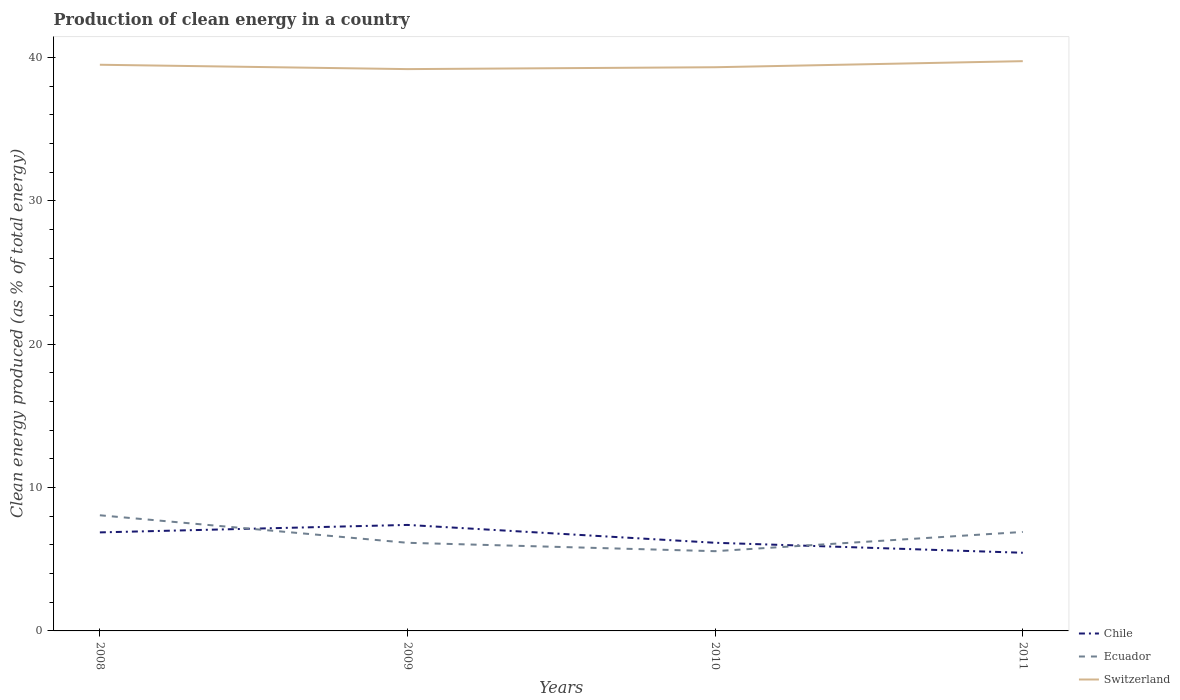How many different coloured lines are there?
Make the answer very short. 3. Does the line corresponding to Ecuador intersect with the line corresponding to Chile?
Provide a short and direct response. Yes. Is the number of lines equal to the number of legend labels?
Make the answer very short. Yes. Across all years, what is the maximum percentage of clean energy produced in Chile?
Give a very brief answer. 5.45. In which year was the percentage of clean energy produced in Ecuador maximum?
Your response must be concise. 2010. What is the total percentage of clean energy produced in Ecuador in the graph?
Provide a succinct answer. 0.58. What is the difference between the highest and the second highest percentage of clean energy produced in Ecuador?
Give a very brief answer. 2.5. Is the percentage of clean energy produced in Chile strictly greater than the percentage of clean energy produced in Switzerland over the years?
Your answer should be very brief. Yes. What is the difference between two consecutive major ticks on the Y-axis?
Your answer should be very brief. 10. Are the values on the major ticks of Y-axis written in scientific E-notation?
Give a very brief answer. No. Does the graph contain any zero values?
Provide a short and direct response. No. Where does the legend appear in the graph?
Make the answer very short. Bottom right. How are the legend labels stacked?
Ensure brevity in your answer.  Vertical. What is the title of the graph?
Your answer should be very brief. Production of clean energy in a country. Does "High income: nonOECD" appear as one of the legend labels in the graph?
Keep it short and to the point. No. What is the label or title of the X-axis?
Your response must be concise. Years. What is the label or title of the Y-axis?
Ensure brevity in your answer.  Clean energy produced (as % of total energy). What is the Clean energy produced (as % of total energy) of Chile in 2008?
Provide a short and direct response. 6.87. What is the Clean energy produced (as % of total energy) in Ecuador in 2008?
Keep it short and to the point. 8.07. What is the Clean energy produced (as % of total energy) in Switzerland in 2008?
Give a very brief answer. 39.49. What is the Clean energy produced (as % of total energy) of Chile in 2009?
Provide a succinct answer. 7.39. What is the Clean energy produced (as % of total energy) of Ecuador in 2009?
Ensure brevity in your answer.  6.15. What is the Clean energy produced (as % of total energy) of Switzerland in 2009?
Offer a terse response. 39.19. What is the Clean energy produced (as % of total energy) of Chile in 2010?
Provide a short and direct response. 6.15. What is the Clean energy produced (as % of total energy) in Ecuador in 2010?
Provide a succinct answer. 5.56. What is the Clean energy produced (as % of total energy) in Switzerland in 2010?
Keep it short and to the point. 39.32. What is the Clean energy produced (as % of total energy) in Chile in 2011?
Offer a terse response. 5.45. What is the Clean energy produced (as % of total energy) in Ecuador in 2011?
Your response must be concise. 6.9. What is the Clean energy produced (as % of total energy) in Switzerland in 2011?
Give a very brief answer. 39.74. Across all years, what is the maximum Clean energy produced (as % of total energy) of Chile?
Your response must be concise. 7.39. Across all years, what is the maximum Clean energy produced (as % of total energy) in Ecuador?
Keep it short and to the point. 8.07. Across all years, what is the maximum Clean energy produced (as % of total energy) in Switzerland?
Give a very brief answer. 39.74. Across all years, what is the minimum Clean energy produced (as % of total energy) of Chile?
Offer a very short reply. 5.45. Across all years, what is the minimum Clean energy produced (as % of total energy) in Ecuador?
Make the answer very short. 5.56. Across all years, what is the minimum Clean energy produced (as % of total energy) in Switzerland?
Ensure brevity in your answer.  39.19. What is the total Clean energy produced (as % of total energy) in Chile in the graph?
Your answer should be compact. 25.87. What is the total Clean energy produced (as % of total energy) in Ecuador in the graph?
Provide a short and direct response. 26.68. What is the total Clean energy produced (as % of total energy) of Switzerland in the graph?
Provide a succinct answer. 157.74. What is the difference between the Clean energy produced (as % of total energy) of Chile in 2008 and that in 2009?
Provide a succinct answer. -0.52. What is the difference between the Clean energy produced (as % of total energy) in Ecuador in 2008 and that in 2009?
Give a very brief answer. 1.92. What is the difference between the Clean energy produced (as % of total energy) in Switzerland in 2008 and that in 2009?
Your answer should be very brief. 0.3. What is the difference between the Clean energy produced (as % of total energy) of Chile in 2008 and that in 2010?
Offer a very short reply. 0.72. What is the difference between the Clean energy produced (as % of total energy) of Ecuador in 2008 and that in 2010?
Offer a very short reply. 2.5. What is the difference between the Clean energy produced (as % of total energy) of Switzerland in 2008 and that in 2010?
Offer a terse response. 0.17. What is the difference between the Clean energy produced (as % of total energy) in Chile in 2008 and that in 2011?
Provide a short and direct response. 1.42. What is the difference between the Clean energy produced (as % of total energy) of Ecuador in 2008 and that in 2011?
Provide a short and direct response. 1.16. What is the difference between the Clean energy produced (as % of total energy) of Switzerland in 2008 and that in 2011?
Your answer should be very brief. -0.25. What is the difference between the Clean energy produced (as % of total energy) of Chile in 2009 and that in 2010?
Offer a terse response. 1.25. What is the difference between the Clean energy produced (as % of total energy) in Ecuador in 2009 and that in 2010?
Provide a short and direct response. 0.58. What is the difference between the Clean energy produced (as % of total energy) of Switzerland in 2009 and that in 2010?
Provide a succinct answer. -0.13. What is the difference between the Clean energy produced (as % of total energy) in Chile in 2009 and that in 2011?
Provide a short and direct response. 1.94. What is the difference between the Clean energy produced (as % of total energy) of Ecuador in 2009 and that in 2011?
Keep it short and to the point. -0.76. What is the difference between the Clean energy produced (as % of total energy) in Switzerland in 2009 and that in 2011?
Ensure brevity in your answer.  -0.55. What is the difference between the Clean energy produced (as % of total energy) of Chile in 2010 and that in 2011?
Offer a very short reply. 0.7. What is the difference between the Clean energy produced (as % of total energy) in Ecuador in 2010 and that in 2011?
Provide a succinct answer. -1.34. What is the difference between the Clean energy produced (as % of total energy) in Switzerland in 2010 and that in 2011?
Provide a short and direct response. -0.42. What is the difference between the Clean energy produced (as % of total energy) of Chile in 2008 and the Clean energy produced (as % of total energy) of Ecuador in 2009?
Provide a succinct answer. 0.73. What is the difference between the Clean energy produced (as % of total energy) of Chile in 2008 and the Clean energy produced (as % of total energy) of Switzerland in 2009?
Ensure brevity in your answer.  -32.31. What is the difference between the Clean energy produced (as % of total energy) of Ecuador in 2008 and the Clean energy produced (as % of total energy) of Switzerland in 2009?
Your answer should be very brief. -31.12. What is the difference between the Clean energy produced (as % of total energy) in Chile in 2008 and the Clean energy produced (as % of total energy) in Ecuador in 2010?
Give a very brief answer. 1.31. What is the difference between the Clean energy produced (as % of total energy) in Chile in 2008 and the Clean energy produced (as % of total energy) in Switzerland in 2010?
Your response must be concise. -32.44. What is the difference between the Clean energy produced (as % of total energy) of Ecuador in 2008 and the Clean energy produced (as % of total energy) of Switzerland in 2010?
Ensure brevity in your answer.  -31.25. What is the difference between the Clean energy produced (as % of total energy) in Chile in 2008 and the Clean energy produced (as % of total energy) in Ecuador in 2011?
Provide a short and direct response. -0.03. What is the difference between the Clean energy produced (as % of total energy) of Chile in 2008 and the Clean energy produced (as % of total energy) of Switzerland in 2011?
Keep it short and to the point. -32.87. What is the difference between the Clean energy produced (as % of total energy) in Ecuador in 2008 and the Clean energy produced (as % of total energy) in Switzerland in 2011?
Give a very brief answer. -31.67. What is the difference between the Clean energy produced (as % of total energy) in Chile in 2009 and the Clean energy produced (as % of total energy) in Ecuador in 2010?
Ensure brevity in your answer.  1.83. What is the difference between the Clean energy produced (as % of total energy) in Chile in 2009 and the Clean energy produced (as % of total energy) in Switzerland in 2010?
Ensure brevity in your answer.  -31.92. What is the difference between the Clean energy produced (as % of total energy) of Ecuador in 2009 and the Clean energy produced (as % of total energy) of Switzerland in 2010?
Provide a short and direct response. -33.17. What is the difference between the Clean energy produced (as % of total energy) of Chile in 2009 and the Clean energy produced (as % of total energy) of Ecuador in 2011?
Your answer should be very brief. 0.49. What is the difference between the Clean energy produced (as % of total energy) in Chile in 2009 and the Clean energy produced (as % of total energy) in Switzerland in 2011?
Offer a very short reply. -32.35. What is the difference between the Clean energy produced (as % of total energy) of Ecuador in 2009 and the Clean energy produced (as % of total energy) of Switzerland in 2011?
Offer a very short reply. -33.59. What is the difference between the Clean energy produced (as % of total energy) of Chile in 2010 and the Clean energy produced (as % of total energy) of Ecuador in 2011?
Offer a very short reply. -0.76. What is the difference between the Clean energy produced (as % of total energy) in Chile in 2010 and the Clean energy produced (as % of total energy) in Switzerland in 2011?
Provide a succinct answer. -33.59. What is the difference between the Clean energy produced (as % of total energy) in Ecuador in 2010 and the Clean energy produced (as % of total energy) in Switzerland in 2011?
Offer a very short reply. -34.18. What is the average Clean energy produced (as % of total energy) of Chile per year?
Offer a terse response. 6.47. What is the average Clean energy produced (as % of total energy) in Ecuador per year?
Offer a very short reply. 6.67. What is the average Clean energy produced (as % of total energy) in Switzerland per year?
Provide a succinct answer. 39.43. In the year 2008, what is the difference between the Clean energy produced (as % of total energy) in Chile and Clean energy produced (as % of total energy) in Ecuador?
Offer a very short reply. -1.19. In the year 2008, what is the difference between the Clean energy produced (as % of total energy) in Chile and Clean energy produced (as % of total energy) in Switzerland?
Ensure brevity in your answer.  -32.62. In the year 2008, what is the difference between the Clean energy produced (as % of total energy) of Ecuador and Clean energy produced (as % of total energy) of Switzerland?
Keep it short and to the point. -31.42. In the year 2009, what is the difference between the Clean energy produced (as % of total energy) of Chile and Clean energy produced (as % of total energy) of Ecuador?
Your response must be concise. 1.25. In the year 2009, what is the difference between the Clean energy produced (as % of total energy) of Chile and Clean energy produced (as % of total energy) of Switzerland?
Offer a terse response. -31.79. In the year 2009, what is the difference between the Clean energy produced (as % of total energy) in Ecuador and Clean energy produced (as % of total energy) in Switzerland?
Give a very brief answer. -33.04. In the year 2010, what is the difference between the Clean energy produced (as % of total energy) of Chile and Clean energy produced (as % of total energy) of Ecuador?
Your answer should be compact. 0.59. In the year 2010, what is the difference between the Clean energy produced (as % of total energy) of Chile and Clean energy produced (as % of total energy) of Switzerland?
Offer a terse response. -33.17. In the year 2010, what is the difference between the Clean energy produced (as % of total energy) of Ecuador and Clean energy produced (as % of total energy) of Switzerland?
Provide a succinct answer. -33.76. In the year 2011, what is the difference between the Clean energy produced (as % of total energy) in Chile and Clean energy produced (as % of total energy) in Ecuador?
Your answer should be very brief. -1.45. In the year 2011, what is the difference between the Clean energy produced (as % of total energy) in Chile and Clean energy produced (as % of total energy) in Switzerland?
Offer a terse response. -34.29. In the year 2011, what is the difference between the Clean energy produced (as % of total energy) of Ecuador and Clean energy produced (as % of total energy) of Switzerland?
Your answer should be very brief. -32.84. What is the ratio of the Clean energy produced (as % of total energy) in Chile in 2008 to that in 2009?
Provide a succinct answer. 0.93. What is the ratio of the Clean energy produced (as % of total energy) of Ecuador in 2008 to that in 2009?
Give a very brief answer. 1.31. What is the ratio of the Clean energy produced (as % of total energy) of Switzerland in 2008 to that in 2009?
Your response must be concise. 1.01. What is the ratio of the Clean energy produced (as % of total energy) in Chile in 2008 to that in 2010?
Provide a succinct answer. 1.12. What is the ratio of the Clean energy produced (as % of total energy) of Ecuador in 2008 to that in 2010?
Provide a succinct answer. 1.45. What is the ratio of the Clean energy produced (as % of total energy) in Chile in 2008 to that in 2011?
Give a very brief answer. 1.26. What is the ratio of the Clean energy produced (as % of total energy) in Ecuador in 2008 to that in 2011?
Ensure brevity in your answer.  1.17. What is the ratio of the Clean energy produced (as % of total energy) of Switzerland in 2008 to that in 2011?
Your response must be concise. 0.99. What is the ratio of the Clean energy produced (as % of total energy) in Chile in 2009 to that in 2010?
Your response must be concise. 1.2. What is the ratio of the Clean energy produced (as % of total energy) in Ecuador in 2009 to that in 2010?
Offer a terse response. 1.11. What is the ratio of the Clean energy produced (as % of total energy) of Switzerland in 2009 to that in 2010?
Provide a succinct answer. 1. What is the ratio of the Clean energy produced (as % of total energy) of Chile in 2009 to that in 2011?
Offer a very short reply. 1.36. What is the ratio of the Clean energy produced (as % of total energy) of Ecuador in 2009 to that in 2011?
Your answer should be very brief. 0.89. What is the ratio of the Clean energy produced (as % of total energy) of Switzerland in 2009 to that in 2011?
Keep it short and to the point. 0.99. What is the ratio of the Clean energy produced (as % of total energy) of Chile in 2010 to that in 2011?
Provide a succinct answer. 1.13. What is the ratio of the Clean energy produced (as % of total energy) of Ecuador in 2010 to that in 2011?
Give a very brief answer. 0.81. What is the ratio of the Clean energy produced (as % of total energy) in Switzerland in 2010 to that in 2011?
Your answer should be compact. 0.99. What is the difference between the highest and the second highest Clean energy produced (as % of total energy) of Chile?
Ensure brevity in your answer.  0.52. What is the difference between the highest and the second highest Clean energy produced (as % of total energy) in Ecuador?
Ensure brevity in your answer.  1.16. What is the difference between the highest and the second highest Clean energy produced (as % of total energy) of Switzerland?
Your answer should be very brief. 0.25. What is the difference between the highest and the lowest Clean energy produced (as % of total energy) of Chile?
Your response must be concise. 1.94. What is the difference between the highest and the lowest Clean energy produced (as % of total energy) in Ecuador?
Keep it short and to the point. 2.5. What is the difference between the highest and the lowest Clean energy produced (as % of total energy) in Switzerland?
Your response must be concise. 0.55. 